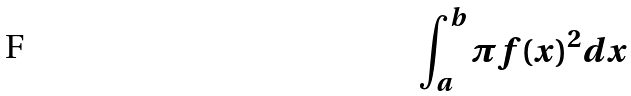<formula> <loc_0><loc_0><loc_500><loc_500>\int _ { a } ^ { b } \pi f ( x ) ^ { 2 } d x</formula> 